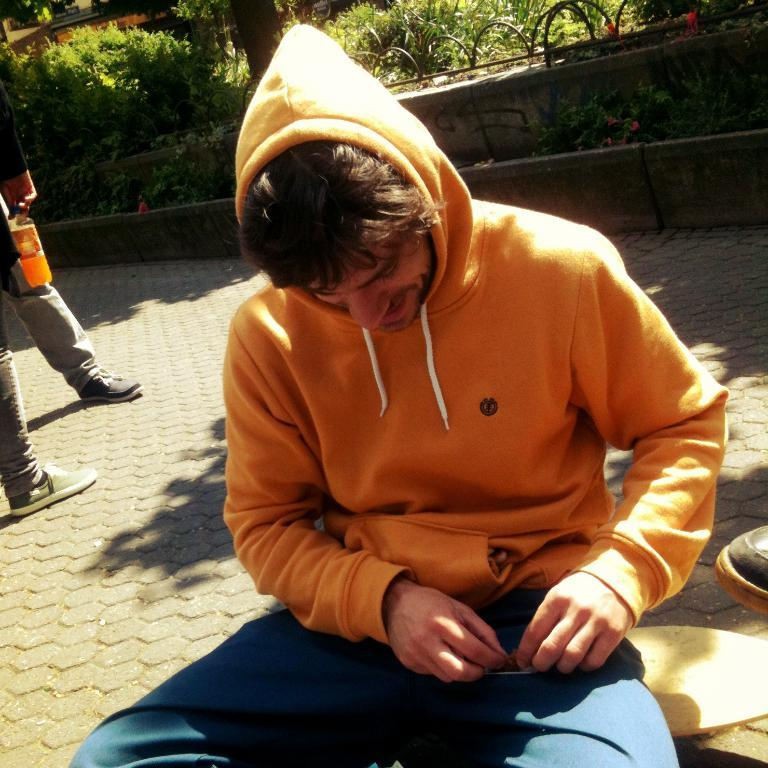How many people are in the image? There are people in the image, but the exact number is not specified. What is the position of one of the people in the image? One person is sitting in the image. What can be seen beneath the people in the image? The ground is visible in the image. What structures are present in the image? There is a wall and a fence in the image. What type of vegetation is present in the image? There are plants in the image. How many geese are observed in the image? There are no geese present in the image. What is the reason for the person's cry in the image? There is no mention of anyone crying in the image. 